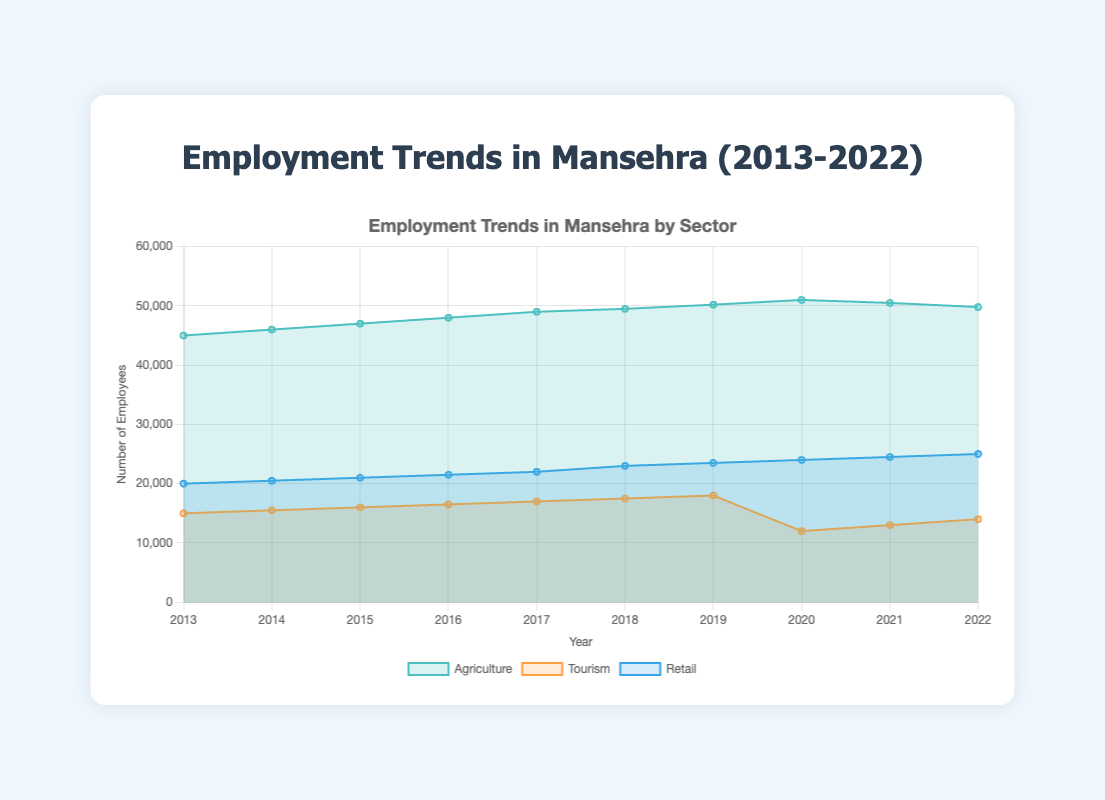Which sector had the highest employment in 2022? To determine the highest employment sector in 2022, look at the data for each sector in that year. Agriculture had 49,800 employees, Tourism had 14,000, and Retail had 25,000. Therefore, Agriculture had the highest employment in 2022.
Answer: Agriculture How did Tourism employment change from 2019 to 2020? Examine the employment figures for Tourism in 2019 and 2020. In 2019, there were 18,000 employees and in 2020, there were 12,000 employees. The change is 18,000 minus 12,000, which equals a decrease of 6,000 employees.
Answer: Decreased by 6,000 What is the general trend of employment in the Agriculture sector over the last 10 years? Look at the employment numbers in Agriculture from 2013 to 2022. The trend shows a general increase from 45,000 in 2013 to a peak of 51,000 in 2020, followed by a slight decline to 49,800 in 2022.
Answer: Generally increasing with a slight decline at the end Which year did Retail employment first reach 23,000 employees? Search through the Retail employment data to find the year when the number first reached 23,000. This happens in 2018.
Answer: 2018 Between which consecutive years did Agriculture employment see the highest increase? Compare the year-over-year differences in Agriculture employment. The highest increase occurred between 2018 and 2019, with an increase of 700 employees (50,200 minus 49,500).
Answer: 2018 to 2019 What is the average employment in the Tourism sector from 2013 to 2022? Sum up the employment numbers for Tourism across those years and divide by the number of years: (15,000 + 15,500 + 16,000 + 16,500 + 17,000 + 17,500 + 18,000 + 12,000 + 13,000 + 14,000) / 10 = 154,500 / 10 = 15,450.
Answer: 15,450 Which sector showed the least variation in employment over the 10 years? Calculate the range of employment for each sector: Agriculture (51,000 - 45,000), Tourism (18,000 - 12,000), Retail (25,000 - 20,000). The range is smallest for Retail, showing the least variation.
Answer: Retail How did the pandemic year (2020) affect employment in the Tourism sector? Look at the employment before and in 2020: 18,000 in 2019 dropped to 12,000 in 2020. This shows a sharp decline in Tourism employment.
Answer: Sharp decline by 6,000 What was the employment difference between Agriculture and Retail in 2016? Subtract the Retail employment from Agriculture employment in 2016: 48,000 (Agriculture) - 21,500 (Retail) = 26,500.
Answer: 26,500 Considering only the last 5 years, which sector experienced the most growth? Compare the employment figures in 2022 to 2018 for each sector: Agriculture (49,800 - 49,500 = +300), Tourism (14,000 - 17,500 = -3,500), Retail (25,000 - 23,000 = +2,000). Retail experienced the most growth.
Answer: Retail 